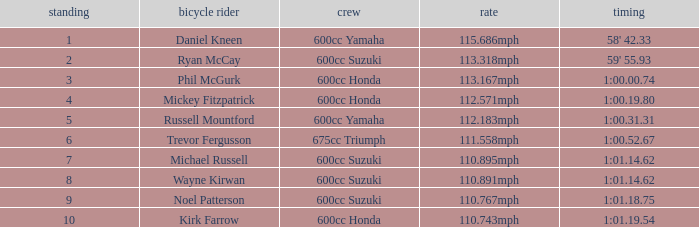How many ranks have 1:01.14.62 as the time, with michael russell as the rider? 1.0. 